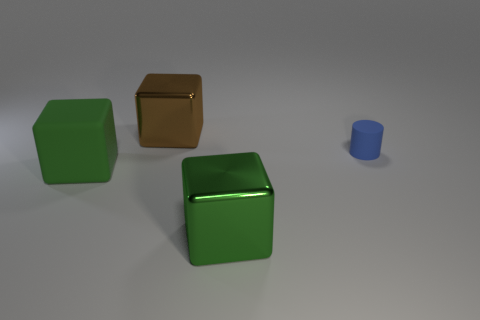Add 1 brown things. How many objects exist? 5 Subtract all shiny blocks. How many blocks are left? 1 Subtract all blocks. How many objects are left? 1 Subtract all blue spheres. How many green cubes are left? 2 Subtract all green cubes. How many cubes are left? 1 Subtract 3 cubes. How many cubes are left? 0 Add 3 big blocks. How many big blocks exist? 6 Subtract 0 cyan cylinders. How many objects are left? 4 Subtract all red cylinders. Subtract all green cubes. How many cylinders are left? 1 Subtract all small rubber things. Subtract all brown metallic objects. How many objects are left? 2 